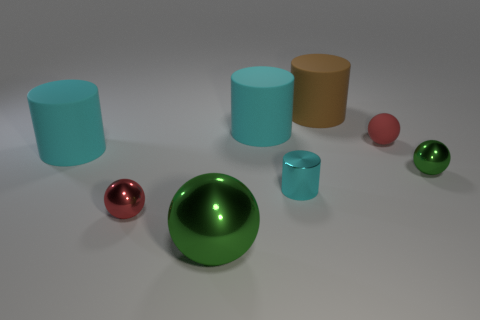Subtract all yellow spheres. How many cyan cylinders are left? 3 Subtract all brown cylinders. How many cylinders are left? 3 Subtract all cyan metallic cylinders. How many cylinders are left? 3 Add 1 tiny green metal things. How many objects exist? 9 Subtract all blue balls. Subtract all green cylinders. How many balls are left? 4 Add 3 tiny red matte objects. How many tiny red matte objects are left? 4 Add 4 small cyan matte balls. How many small cyan matte balls exist? 4 Subtract 0 cyan blocks. How many objects are left? 8 Subtract all tiny rubber objects. Subtract all large purple balls. How many objects are left? 7 